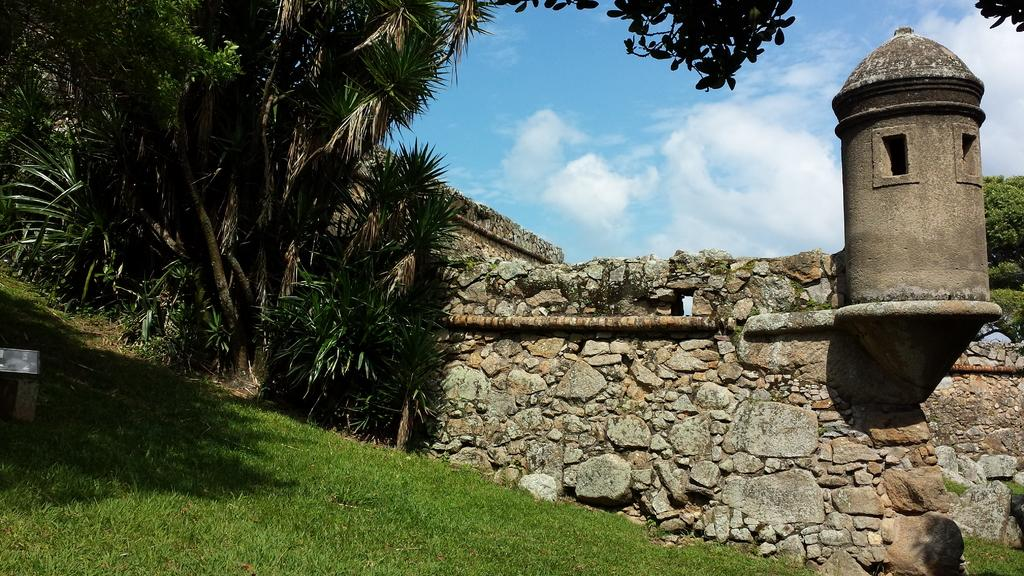What type of structure can be seen in the image? There is a wall in the image. What is covering the ground in the image? There is grass on the floor in the image. What type of vegetation is on the right side of the image? There are trees on the right side of the image. What is the condition of the sky in the image? The sky is clear in the image. How many people are wearing masks in the crowd in the image? There is no crowd or people wearing masks present in the image; it features a wall, grass, trees, and a clear sky. What type of silk is draped over the trees in the image? There is no silk present in the image; it features a wall, grass, trees, and a clear sky. 